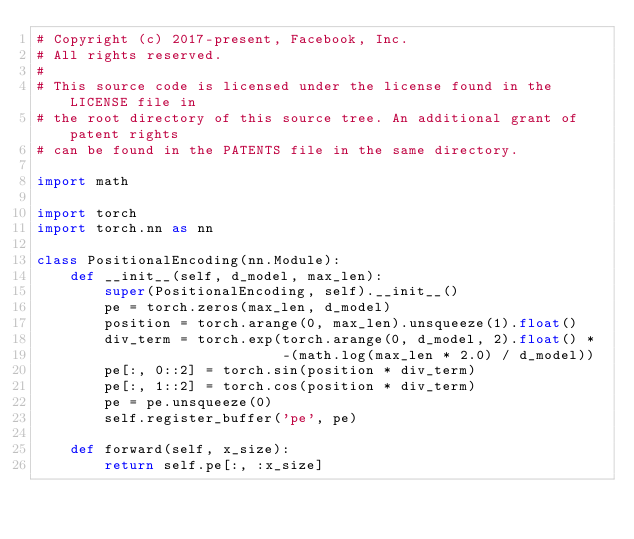<code> <loc_0><loc_0><loc_500><loc_500><_Python_># Copyright (c) 2017-present, Facebook, Inc.
# All rights reserved.
#
# This source code is licensed under the license found in the LICENSE file in
# the root directory of this source tree. An additional grant of patent rights
# can be found in the PATENTS file in the same directory.

import math

import torch
import torch.nn as nn

class PositionalEncoding(nn.Module):
    def __init__(self, d_model, max_len):
        super(PositionalEncoding, self).__init__()   
        pe = torch.zeros(max_len, d_model)
        position = torch.arange(0, max_len).unsqueeze(1).float()
        div_term = torch.exp(torch.arange(0, d_model, 2).float() *
                             -(math.log(max_len * 2.0) / d_model))
        pe[:, 0::2] = torch.sin(position * div_term)
        pe[:, 1::2] = torch.cos(position * div_term)
        pe = pe.unsqueeze(0)
        self.register_buffer('pe', pe)

    def forward(self, x_size):
        return self.pe[:, :x_size]</code> 